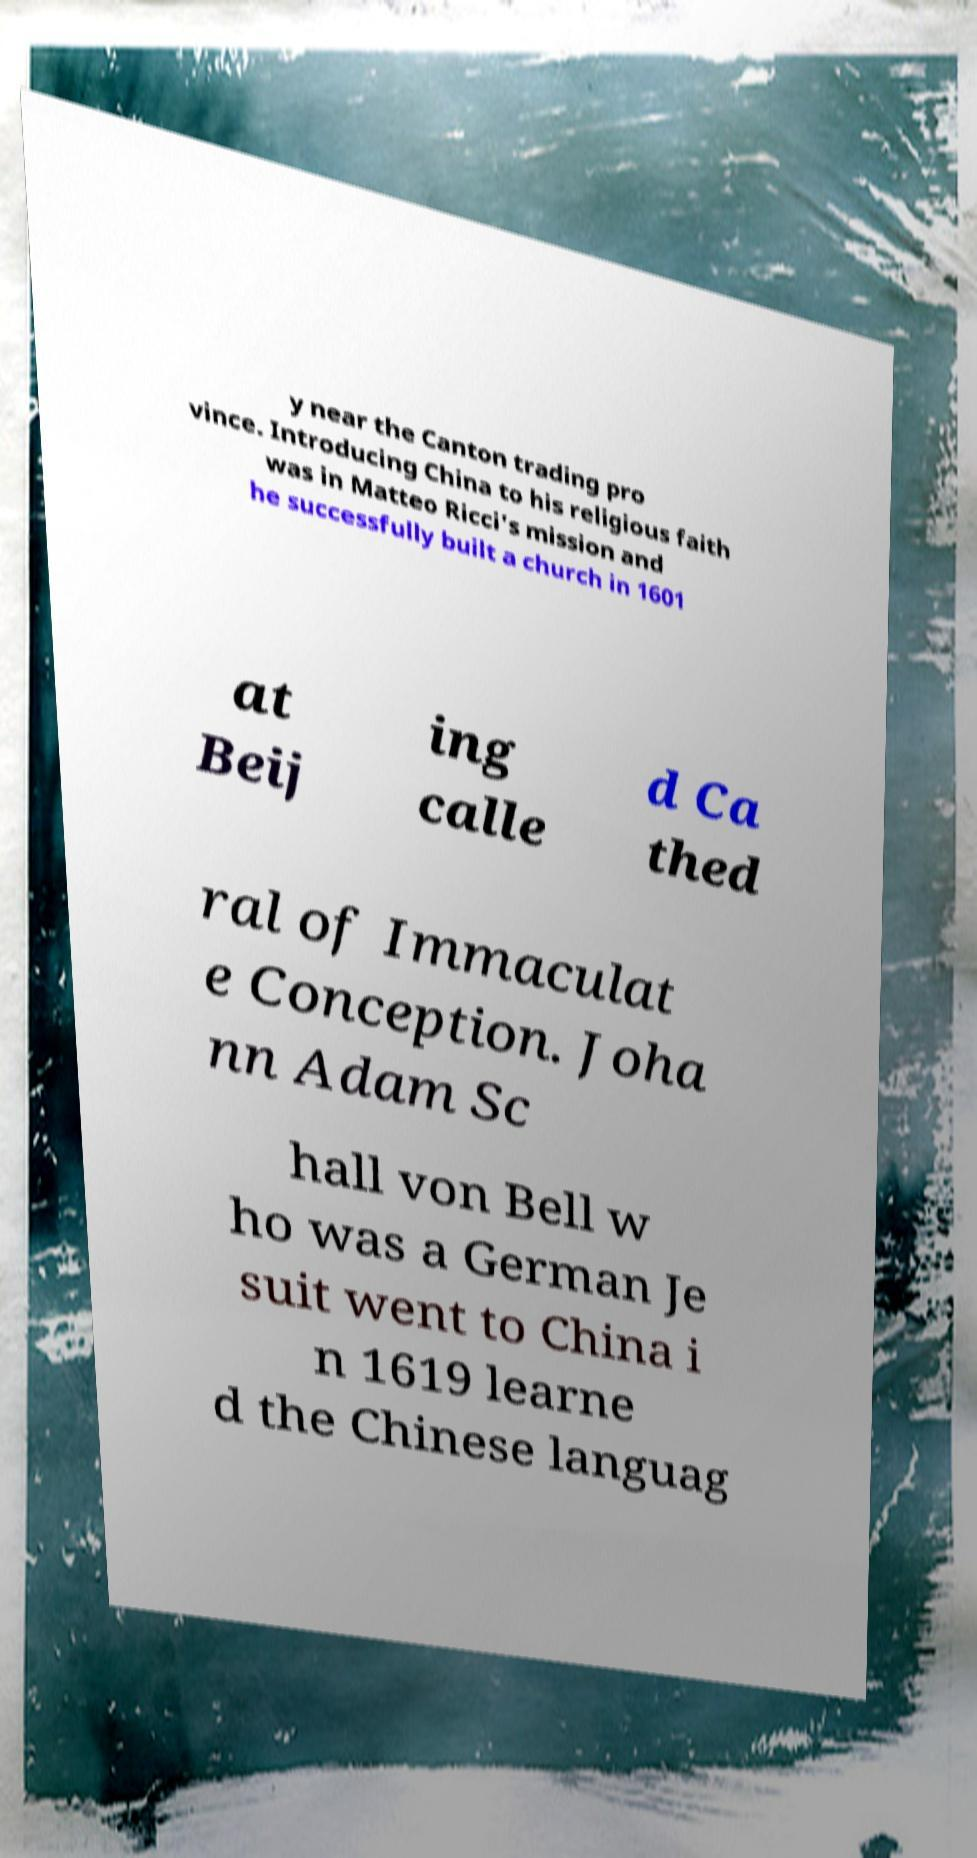Please identify and transcribe the text found in this image. y near the Canton trading pro vince. Introducing China to his religious faith was in Matteo Ricci's mission and he successfully built a church in 1601 at Beij ing calle d Ca thed ral of Immaculat e Conception. Joha nn Adam Sc hall von Bell w ho was a German Je suit went to China i n 1619 learne d the Chinese languag 